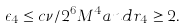Convert formula to latex. <formula><loc_0><loc_0><loc_500><loc_500>\epsilon _ { 4 } \leq c \nu / 2 ^ { 6 } M ^ { 4 } a n d r _ { 4 } \geq 2 .</formula> 